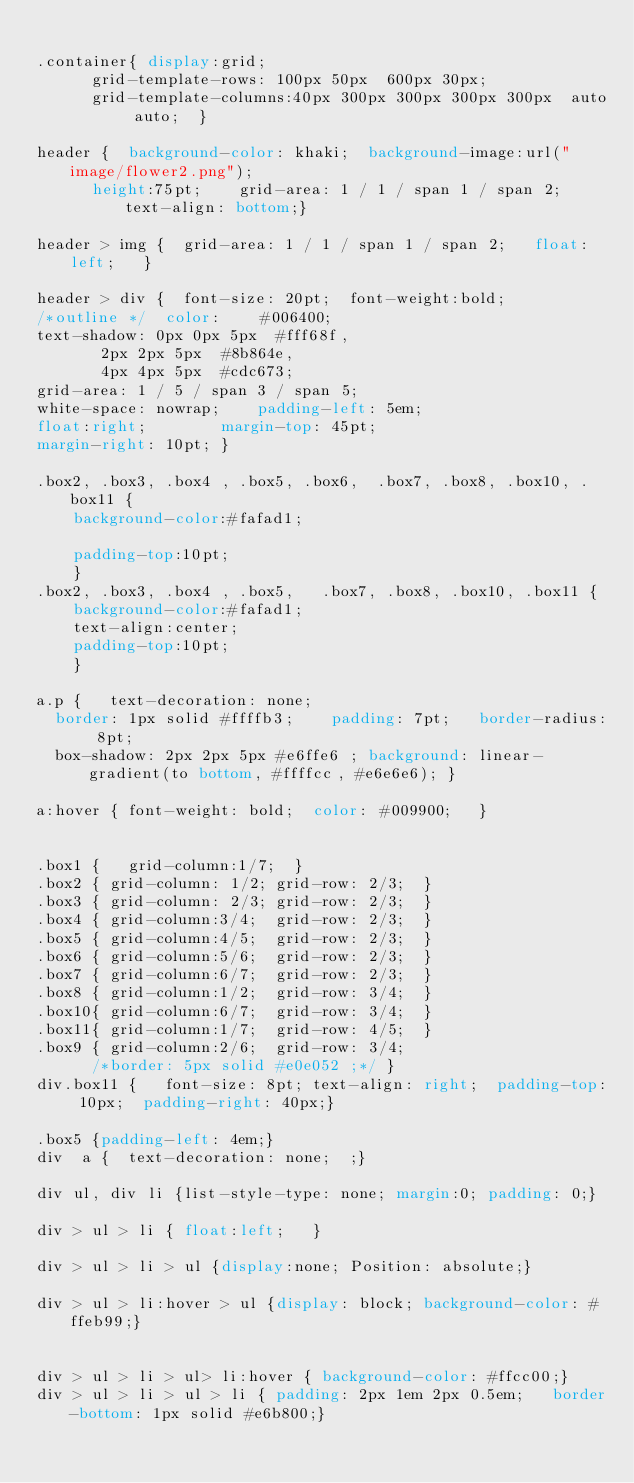<code> <loc_0><loc_0><loc_500><loc_500><_CSS_>
.container{	display:grid;
			grid-template-rows: 100px 50px  600px 30px;
			grid-template-columns:40px 300px 300px 300px 300px  auto auto;	}

header {	background-color: khaki;	background-image:url("image/flower2.png");
			height:75pt;		grid-area: 1 / 1 / span 1 / span 2;		text-align: bottom;}
	
header > img {	grid-area: 1 / 1 / span 1 / span 2;		float:left;		}

header > div {	font-size: 20pt;	font-weight:bold;
/*outline */	color:		#006400;
text-shadow: 0px 0px 5px 	#fff68f,
			 2px 2px 5px 	#8b864e,
			 4px 4px 5px 	#cdc673;
grid-area: 1 / 5 / span 3 / span 5;
white-space: nowrap;		padding-left: 5em;
float:right;				margin-top: 45pt;
margin-right: 10pt;	}
	
.box2, .box3, .box4 , .box5, .box6,  .box7, .box8, .box10, .box11	{
		background-color:#fafad1;
		
		padding-top:10pt;	
		}
.box2, .box3, .box4 , .box5,   .box7, .box8, .box10, .box11	{
		background-color:#fafad1;
		text-align:center;
		padding-top:10pt;	
		}
	
a.p { 	text-decoration: none; 	
	border: 1px solid #ffffb3;		padding: 7pt;		border-radius: 8pt;
	box-shadow: 2px 2px 5px #e6ffe6	;	background: linear-gradient(to bottom, #ffffcc, #e6e6e6); }
	
a:hover {	font-weight: bold;	color: #009900;		}


.box1 {		grid-column:1/7;	}
.box2 {	grid-column: 1/2;	grid-row: 2/3;	}
.box3 {	grid-column: 2/3;	grid-row: 2/3;	}
.box4 {	grid-column:3/4;	grid-row: 2/3;	}
.box5 {	grid-column:4/5;	grid-row: 2/3;	}
.box6 {	grid-column:5/6;	grid-row: 2/3;	}
.box7 {	grid-column:6/7;	grid-row: 2/3;	}
.box8 {	grid-column:1/2;	grid-row: 3/4;	}
.box10{	grid-column:6/7;	grid-row: 3/4; 	}
.box11{	grid-column:1/7;	grid-row: 4/5;	}
.box9 {	grid-column:2/6;	grid-row: 3/4;
			/*border: 5px solid #e0e052 ;*/	}
div.box11 {		font-size: 8pt;	text-align: right;	padding-top: 10px;	padding-right: 40px;}

.box5 {padding-left: 4em;}
div  a {	text-decoration: none;	;}

div ul, div li {list-style-type: none; margin:0; padding: 0;}

div > ul > li {	float:left; 	}

div > ul > li > ul {display:none; Position: absolute;}

div > ul > li:hover > ul {display: block; background-color: #ffeb99;}
 

div > ul > li > ul> li:hover { background-color: #ffcc00;}
div > ul > li > ul > li { padding: 2px 1em 2px 0.5em; 	border-bottom: 1px solid #e6b800;}





</code> 